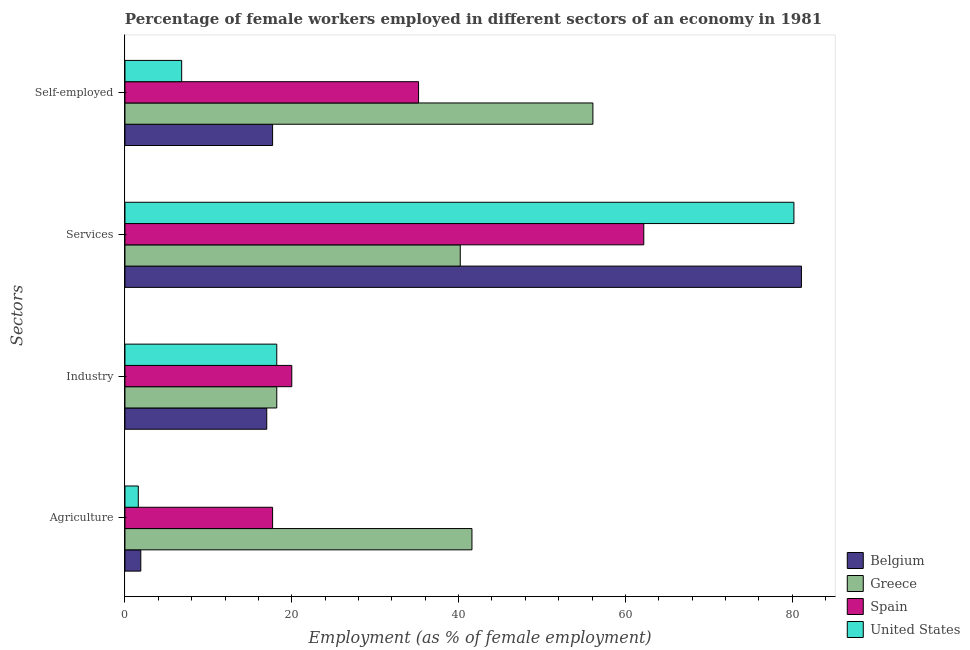How many different coloured bars are there?
Ensure brevity in your answer.  4. How many groups of bars are there?
Keep it short and to the point. 4. Are the number of bars on each tick of the Y-axis equal?
Offer a very short reply. Yes. How many bars are there on the 3rd tick from the bottom?
Your response must be concise. 4. What is the label of the 2nd group of bars from the top?
Offer a terse response. Services. What is the percentage of female workers in services in Spain?
Give a very brief answer. 62.2. Across all countries, what is the maximum percentage of female workers in services?
Provide a short and direct response. 81.1. Across all countries, what is the minimum percentage of female workers in services?
Your response must be concise. 40.2. What is the total percentage of self employed female workers in the graph?
Ensure brevity in your answer.  115.8. What is the difference between the percentage of female workers in services in United States and that in Belgium?
Make the answer very short. -0.9. What is the difference between the percentage of self employed female workers in Greece and the percentage of female workers in services in Spain?
Offer a very short reply. -6.1. What is the average percentage of female workers in industry per country?
Keep it short and to the point. 18.35. What is the difference between the percentage of female workers in agriculture and percentage of female workers in industry in Belgium?
Give a very brief answer. -15.1. In how many countries, is the percentage of female workers in services greater than 24 %?
Offer a terse response. 4. What is the ratio of the percentage of female workers in services in United States to that in Greece?
Offer a very short reply. 2. Is the percentage of female workers in industry in Greece less than that in Spain?
Make the answer very short. Yes. Is the difference between the percentage of female workers in agriculture in United States and Spain greater than the difference between the percentage of self employed female workers in United States and Spain?
Provide a short and direct response. Yes. What is the difference between the highest and the second highest percentage of self employed female workers?
Keep it short and to the point. 20.9. What is the difference between the highest and the lowest percentage of female workers in industry?
Keep it short and to the point. 3. In how many countries, is the percentage of self employed female workers greater than the average percentage of self employed female workers taken over all countries?
Offer a very short reply. 2. Is it the case that in every country, the sum of the percentage of female workers in industry and percentage of self employed female workers is greater than the sum of percentage of female workers in services and percentage of female workers in agriculture?
Offer a terse response. No. What does the 3rd bar from the bottom in Self-employed represents?
Ensure brevity in your answer.  Spain. Are all the bars in the graph horizontal?
Keep it short and to the point. Yes. How many countries are there in the graph?
Your answer should be compact. 4. What is the difference between two consecutive major ticks on the X-axis?
Ensure brevity in your answer.  20. Are the values on the major ticks of X-axis written in scientific E-notation?
Provide a succinct answer. No. Does the graph contain grids?
Provide a short and direct response. No. What is the title of the graph?
Offer a very short reply. Percentage of female workers employed in different sectors of an economy in 1981. Does "Kuwait" appear as one of the legend labels in the graph?
Your answer should be compact. No. What is the label or title of the X-axis?
Make the answer very short. Employment (as % of female employment). What is the label or title of the Y-axis?
Your answer should be very brief. Sectors. What is the Employment (as % of female employment) of Belgium in Agriculture?
Ensure brevity in your answer.  1.9. What is the Employment (as % of female employment) in Greece in Agriculture?
Provide a succinct answer. 41.6. What is the Employment (as % of female employment) of Spain in Agriculture?
Keep it short and to the point. 17.7. What is the Employment (as % of female employment) of United States in Agriculture?
Offer a very short reply. 1.6. What is the Employment (as % of female employment) in Greece in Industry?
Offer a terse response. 18.2. What is the Employment (as % of female employment) in United States in Industry?
Keep it short and to the point. 18.2. What is the Employment (as % of female employment) in Belgium in Services?
Make the answer very short. 81.1. What is the Employment (as % of female employment) of Greece in Services?
Offer a very short reply. 40.2. What is the Employment (as % of female employment) in Spain in Services?
Offer a very short reply. 62.2. What is the Employment (as % of female employment) in United States in Services?
Keep it short and to the point. 80.2. What is the Employment (as % of female employment) in Belgium in Self-employed?
Your answer should be very brief. 17.7. What is the Employment (as % of female employment) of Greece in Self-employed?
Offer a very short reply. 56.1. What is the Employment (as % of female employment) of Spain in Self-employed?
Provide a succinct answer. 35.2. What is the Employment (as % of female employment) of United States in Self-employed?
Offer a very short reply. 6.8. Across all Sectors, what is the maximum Employment (as % of female employment) in Belgium?
Your response must be concise. 81.1. Across all Sectors, what is the maximum Employment (as % of female employment) in Greece?
Your response must be concise. 56.1. Across all Sectors, what is the maximum Employment (as % of female employment) in Spain?
Give a very brief answer. 62.2. Across all Sectors, what is the maximum Employment (as % of female employment) of United States?
Ensure brevity in your answer.  80.2. Across all Sectors, what is the minimum Employment (as % of female employment) in Belgium?
Keep it short and to the point. 1.9. Across all Sectors, what is the minimum Employment (as % of female employment) of Greece?
Provide a succinct answer. 18.2. Across all Sectors, what is the minimum Employment (as % of female employment) of Spain?
Provide a short and direct response. 17.7. Across all Sectors, what is the minimum Employment (as % of female employment) of United States?
Your response must be concise. 1.6. What is the total Employment (as % of female employment) in Belgium in the graph?
Provide a succinct answer. 117.7. What is the total Employment (as % of female employment) of Greece in the graph?
Make the answer very short. 156.1. What is the total Employment (as % of female employment) of Spain in the graph?
Your answer should be compact. 135.1. What is the total Employment (as % of female employment) in United States in the graph?
Offer a very short reply. 106.8. What is the difference between the Employment (as % of female employment) in Belgium in Agriculture and that in Industry?
Ensure brevity in your answer.  -15.1. What is the difference between the Employment (as % of female employment) of Greece in Agriculture and that in Industry?
Your answer should be compact. 23.4. What is the difference between the Employment (as % of female employment) in Spain in Agriculture and that in Industry?
Your answer should be very brief. -2.3. What is the difference between the Employment (as % of female employment) in United States in Agriculture and that in Industry?
Offer a very short reply. -16.6. What is the difference between the Employment (as % of female employment) in Belgium in Agriculture and that in Services?
Your answer should be very brief. -79.2. What is the difference between the Employment (as % of female employment) of Greece in Agriculture and that in Services?
Make the answer very short. 1.4. What is the difference between the Employment (as % of female employment) in Spain in Agriculture and that in Services?
Ensure brevity in your answer.  -44.5. What is the difference between the Employment (as % of female employment) in United States in Agriculture and that in Services?
Give a very brief answer. -78.6. What is the difference between the Employment (as % of female employment) in Belgium in Agriculture and that in Self-employed?
Give a very brief answer. -15.8. What is the difference between the Employment (as % of female employment) of Spain in Agriculture and that in Self-employed?
Offer a very short reply. -17.5. What is the difference between the Employment (as % of female employment) in United States in Agriculture and that in Self-employed?
Keep it short and to the point. -5.2. What is the difference between the Employment (as % of female employment) of Belgium in Industry and that in Services?
Keep it short and to the point. -64.1. What is the difference between the Employment (as % of female employment) of Spain in Industry and that in Services?
Provide a short and direct response. -42.2. What is the difference between the Employment (as % of female employment) of United States in Industry and that in Services?
Provide a short and direct response. -62. What is the difference between the Employment (as % of female employment) of Belgium in Industry and that in Self-employed?
Keep it short and to the point. -0.7. What is the difference between the Employment (as % of female employment) in Greece in Industry and that in Self-employed?
Your answer should be very brief. -37.9. What is the difference between the Employment (as % of female employment) in Spain in Industry and that in Self-employed?
Provide a succinct answer. -15.2. What is the difference between the Employment (as % of female employment) of United States in Industry and that in Self-employed?
Provide a short and direct response. 11.4. What is the difference between the Employment (as % of female employment) of Belgium in Services and that in Self-employed?
Offer a terse response. 63.4. What is the difference between the Employment (as % of female employment) in Greece in Services and that in Self-employed?
Make the answer very short. -15.9. What is the difference between the Employment (as % of female employment) in United States in Services and that in Self-employed?
Provide a short and direct response. 73.4. What is the difference between the Employment (as % of female employment) of Belgium in Agriculture and the Employment (as % of female employment) of Greece in Industry?
Provide a succinct answer. -16.3. What is the difference between the Employment (as % of female employment) of Belgium in Agriculture and the Employment (as % of female employment) of Spain in Industry?
Give a very brief answer. -18.1. What is the difference between the Employment (as % of female employment) in Belgium in Agriculture and the Employment (as % of female employment) in United States in Industry?
Make the answer very short. -16.3. What is the difference between the Employment (as % of female employment) of Greece in Agriculture and the Employment (as % of female employment) of Spain in Industry?
Offer a very short reply. 21.6. What is the difference between the Employment (as % of female employment) of Greece in Agriculture and the Employment (as % of female employment) of United States in Industry?
Keep it short and to the point. 23.4. What is the difference between the Employment (as % of female employment) of Belgium in Agriculture and the Employment (as % of female employment) of Greece in Services?
Make the answer very short. -38.3. What is the difference between the Employment (as % of female employment) of Belgium in Agriculture and the Employment (as % of female employment) of Spain in Services?
Provide a succinct answer. -60.3. What is the difference between the Employment (as % of female employment) in Belgium in Agriculture and the Employment (as % of female employment) in United States in Services?
Keep it short and to the point. -78.3. What is the difference between the Employment (as % of female employment) in Greece in Agriculture and the Employment (as % of female employment) in Spain in Services?
Provide a short and direct response. -20.6. What is the difference between the Employment (as % of female employment) of Greece in Agriculture and the Employment (as % of female employment) of United States in Services?
Provide a short and direct response. -38.6. What is the difference between the Employment (as % of female employment) of Spain in Agriculture and the Employment (as % of female employment) of United States in Services?
Offer a terse response. -62.5. What is the difference between the Employment (as % of female employment) of Belgium in Agriculture and the Employment (as % of female employment) of Greece in Self-employed?
Offer a very short reply. -54.2. What is the difference between the Employment (as % of female employment) of Belgium in Agriculture and the Employment (as % of female employment) of Spain in Self-employed?
Offer a very short reply. -33.3. What is the difference between the Employment (as % of female employment) of Belgium in Agriculture and the Employment (as % of female employment) of United States in Self-employed?
Your answer should be compact. -4.9. What is the difference between the Employment (as % of female employment) in Greece in Agriculture and the Employment (as % of female employment) in United States in Self-employed?
Provide a succinct answer. 34.8. What is the difference between the Employment (as % of female employment) in Belgium in Industry and the Employment (as % of female employment) in Greece in Services?
Ensure brevity in your answer.  -23.2. What is the difference between the Employment (as % of female employment) of Belgium in Industry and the Employment (as % of female employment) of Spain in Services?
Your answer should be very brief. -45.2. What is the difference between the Employment (as % of female employment) of Belgium in Industry and the Employment (as % of female employment) of United States in Services?
Give a very brief answer. -63.2. What is the difference between the Employment (as % of female employment) of Greece in Industry and the Employment (as % of female employment) of Spain in Services?
Provide a succinct answer. -44. What is the difference between the Employment (as % of female employment) of Greece in Industry and the Employment (as % of female employment) of United States in Services?
Keep it short and to the point. -62. What is the difference between the Employment (as % of female employment) in Spain in Industry and the Employment (as % of female employment) in United States in Services?
Your answer should be compact. -60.2. What is the difference between the Employment (as % of female employment) of Belgium in Industry and the Employment (as % of female employment) of Greece in Self-employed?
Provide a short and direct response. -39.1. What is the difference between the Employment (as % of female employment) of Belgium in Industry and the Employment (as % of female employment) of Spain in Self-employed?
Offer a very short reply. -18.2. What is the difference between the Employment (as % of female employment) in Greece in Industry and the Employment (as % of female employment) in United States in Self-employed?
Make the answer very short. 11.4. What is the difference between the Employment (as % of female employment) of Spain in Industry and the Employment (as % of female employment) of United States in Self-employed?
Your answer should be very brief. 13.2. What is the difference between the Employment (as % of female employment) of Belgium in Services and the Employment (as % of female employment) of Spain in Self-employed?
Keep it short and to the point. 45.9. What is the difference between the Employment (as % of female employment) in Belgium in Services and the Employment (as % of female employment) in United States in Self-employed?
Offer a terse response. 74.3. What is the difference between the Employment (as % of female employment) in Greece in Services and the Employment (as % of female employment) in Spain in Self-employed?
Ensure brevity in your answer.  5. What is the difference between the Employment (as % of female employment) in Greece in Services and the Employment (as % of female employment) in United States in Self-employed?
Make the answer very short. 33.4. What is the difference between the Employment (as % of female employment) in Spain in Services and the Employment (as % of female employment) in United States in Self-employed?
Give a very brief answer. 55.4. What is the average Employment (as % of female employment) of Belgium per Sectors?
Provide a short and direct response. 29.43. What is the average Employment (as % of female employment) of Greece per Sectors?
Provide a succinct answer. 39.02. What is the average Employment (as % of female employment) in Spain per Sectors?
Make the answer very short. 33.77. What is the average Employment (as % of female employment) of United States per Sectors?
Provide a short and direct response. 26.7. What is the difference between the Employment (as % of female employment) in Belgium and Employment (as % of female employment) in Greece in Agriculture?
Your answer should be very brief. -39.7. What is the difference between the Employment (as % of female employment) of Belgium and Employment (as % of female employment) of Spain in Agriculture?
Provide a succinct answer. -15.8. What is the difference between the Employment (as % of female employment) of Greece and Employment (as % of female employment) of Spain in Agriculture?
Keep it short and to the point. 23.9. What is the difference between the Employment (as % of female employment) of Spain and Employment (as % of female employment) of United States in Agriculture?
Offer a terse response. 16.1. What is the difference between the Employment (as % of female employment) in Greece and Employment (as % of female employment) in United States in Industry?
Provide a short and direct response. 0. What is the difference between the Employment (as % of female employment) of Belgium and Employment (as % of female employment) of Greece in Services?
Keep it short and to the point. 40.9. What is the difference between the Employment (as % of female employment) in Greece and Employment (as % of female employment) in United States in Services?
Give a very brief answer. -40. What is the difference between the Employment (as % of female employment) of Spain and Employment (as % of female employment) of United States in Services?
Provide a succinct answer. -18. What is the difference between the Employment (as % of female employment) of Belgium and Employment (as % of female employment) of Greece in Self-employed?
Offer a terse response. -38.4. What is the difference between the Employment (as % of female employment) of Belgium and Employment (as % of female employment) of Spain in Self-employed?
Provide a short and direct response. -17.5. What is the difference between the Employment (as % of female employment) in Greece and Employment (as % of female employment) in Spain in Self-employed?
Your answer should be compact. 20.9. What is the difference between the Employment (as % of female employment) in Greece and Employment (as % of female employment) in United States in Self-employed?
Provide a short and direct response. 49.3. What is the difference between the Employment (as % of female employment) of Spain and Employment (as % of female employment) of United States in Self-employed?
Give a very brief answer. 28.4. What is the ratio of the Employment (as % of female employment) of Belgium in Agriculture to that in Industry?
Keep it short and to the point. 0.11. What is the ratio of the Employment (as % of female employment) of Greece in Agriculture to that in Industry?
Provide a short and direct response. 2.29. What is the ratio of the Employment (as % of female employment) in Spain in Agriculture to that in Industry?
Provide a succinct answer. 0.89. What is the ratio of the Employment (as % of female employment) of United States in Agriculture to that in Industry?
Keep it short and to the point. 0.09. What is the ratio of the Employment (as % of female employment) in Belgium in Agriculture to that in Services?
Offer a very short reply. 0.02. What is the ratio of the Employment (as % of female employment) of Greece in Agriculture to that in Services?
Ensure brevity in your answer.  1.03. What is the ratio of the Employment (as % of female employment) in Spain in Agriculture to that in Services?
Your answer should be compact. 0.28. What is the ratio of the Employment (as % of female employment) in Belgium in Agriculture to that in Self-employed?
Provide a succinct answer. 0.11. What is the ratio of the Employment (as % of female employment) in Greece in Agriculture to that in Self-employed?
Your answer should be compact. 0.74. What is the ratio of the Employment (as % of female employment) in Spain in Agriculture to that in Self-employed?
Provide a short and direct response. 0.5. What is the ratio of the Employment (as % of female employment) in United States in Agriculture to that in Self-employed?
Your response must be concise. 0.24. What is the ratio of the Employment (as % of female employment) in Belgium in Industry to that in Services?
Ensure brevity in your answer.  0.21. What is the ratio of the Employment (as % of female employment) in Greece in Industry to that in Services?
Your answer should be compact. 0.45. What is the ratio of the Employment (as % of female employment) in Spain in Industry to that in Services?
Ensure brevity in your answer.  0.32. What is the ratio of the Employment (as % of female employment) of United States in Industry to that in Services?
Your response must be concise. 0.23. What is the ratio of the Employment (as % of female employment) of Belgium in Industry to that in Self-employed?
Offer a terse response. 0.96. What is the ratio of the Employment (as % of female employment) in Greece in Industry to that in Self-employed?
Provide a short and direct response. 0.32. What is the ratio of the Employment (as % of female employment) in Spain in Industry to that in Self-employed?
Your answer should be compact. 0.57. What is the ratio of the Employment (as % of female employment) in United States in Industry to that in Self-employed?
Your response must be concise. 2.68. What is the ratio of the Employment (as % of female employment) of Belgium in Services to that in Self-employed?
Provide a short and direct response. 4.58. What is the ratio of the Employment (as % of female employment) of Greece in Services to that in Self-employed?
Keep it short and to the point. 0.72. What is the ratio of the Employment (as % of female employment) in Spain in Services to that in Self-employed?
Your answer should be very brief. 1.77. What is the ratio of the Employment (as % of female employment) in United States in Services to that in Self-employed?
Give a very brief answer. 11.79. What is the difference between the highest and the second highest Employment (as % of female employment) of Belgium?
Ensure brevity in your answer.  63.4. What is the difference between the highest and the second highest Employment (as % of female employment) of United States?
Your answer should be compact. 62. What is the difference between the highest and the lowest Employment (as % of female employment) in Belgium?
Give a very brief answer. 79.2. What is the difference between the highest and the lowest Employment (as % of female employment) in Greece?
Your answer should be compact. 37.9. What is the difference between the highest and the lowest Employment (as % of female employment) in Spain?
Your answer should be very brief. 44.5. What is the difference between the highest and the lowest Employment (as % of female employment) in United States?
Your answer should be very brief. 78.6. 